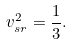Convert formula to latex. <formula><loc_0><loc_0><loc_500><loc_500>v _ { s r } ^ { 2 } = \frac { 1 } { 3 } .</formula> 